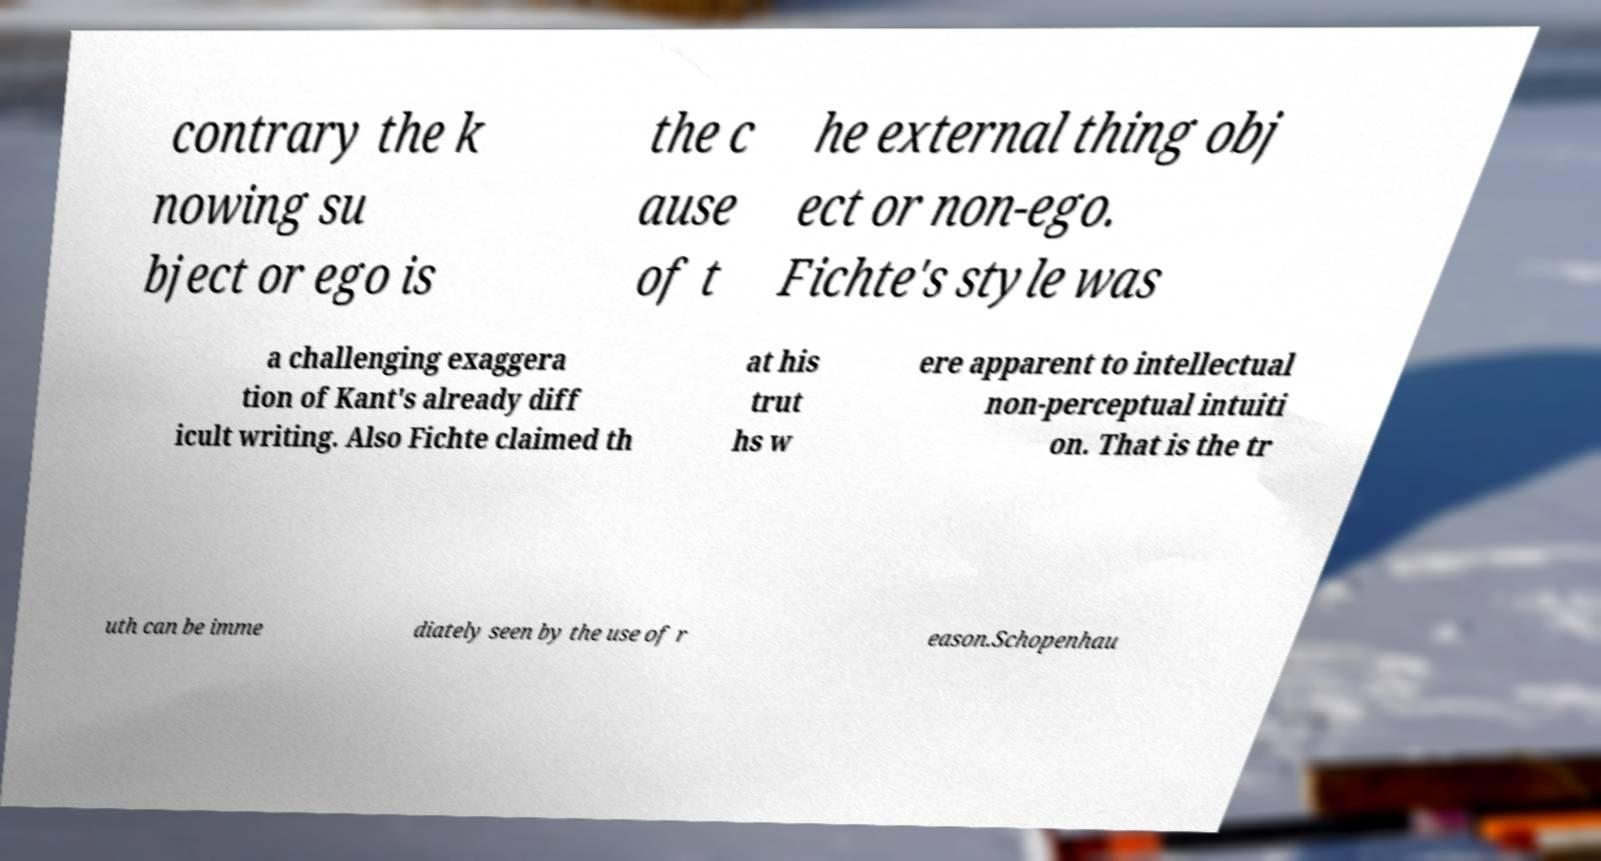Please read and relay the text visible in this image. What does it say? contrary the k nowing su bject or ego is the c ause of t he external thing obj ect or non-ego. Fichte's style was a challenging exaggera tion of Kant's already diff icult writing. Also Fichte claimed th at his trut hs w ere apparent to intellectual non-perceptual intuiti on. That is the tr uth can be imme diately seen by the use of r eason.Schopenhau 